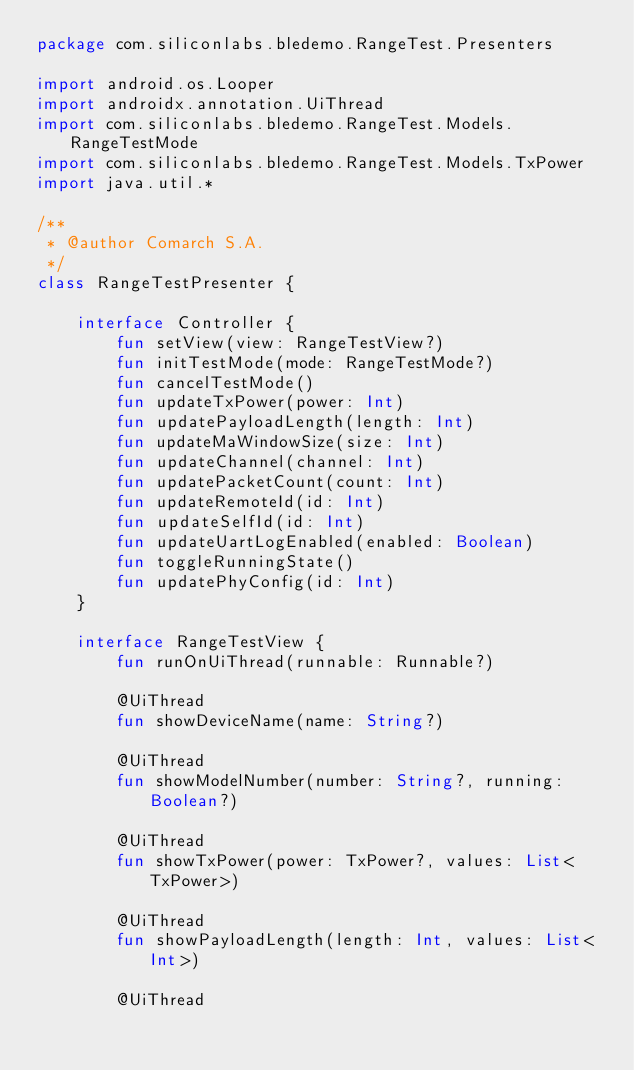Convert code to text. <code><loc_0><loc_0><loc_500><loc_500><_Kotlin_>package com.siliconlabs.bledemo.RangeTest.Presenters

import android.os.Looper
import androidx.annotation.UiThread
import com.siliconlabs.bledemo.RangeTest.Models.RangeTestMode
import com.siliconlabs.bledemo.RangeTest.Models.TxPower
import java.util.*

/**
 * @author Comarch S.A.
 */
class RangeTestPresenter {

    interface Controller {
        fun setView(view: RangeTestView?)
        fun initTestMode(mode: RangeTestMode?)
        fun cancelTestMode()
        fun updateTxPower(power: Int)
        fun updatePayloadLength(length: Int)
        fun updateMaWindowSize(size: Int)
        fun updateChannel(channel: Int)
        fun updatePacketCount(count: Int)
        fun updateRemoteId(id: Int)
        fun updateSelfId(id: Int)
        fun updateUartLogEnabled(enabled: Boolean)
        fun toggleRunningState()
        fun updatePhyConfig(id: Int)
    }

    interface RangeTestView {
        fun runOnUiThread(runnable: Runnable?)

        @UiThread
        fun showDeviceName(name: String?)

        @UiThread
        fun showModelNumber(number: String?, running: Boolean?)

        @UiThread
        fun showTxPower(power: TxPower?, values: List<TxPower>)

        @UiThread
        fun showPayloadLength(length: Int, values: List<Int>)

        @UiThread</code> 